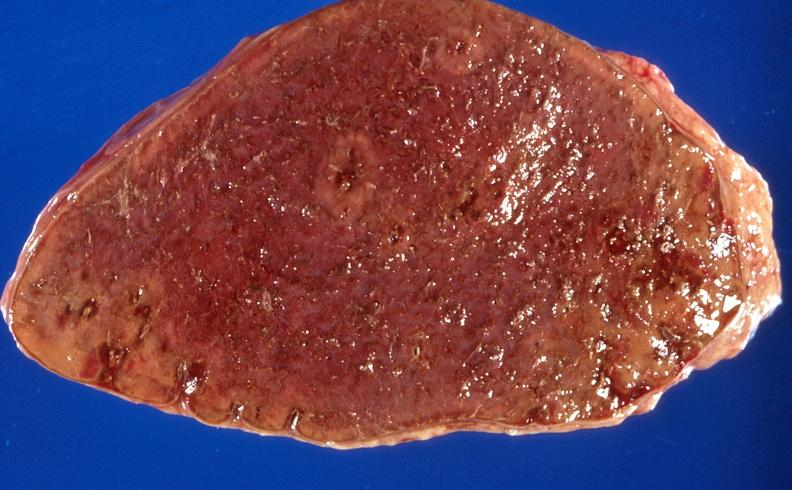s hematologic present?
Answer the question using a single word or phrase. Yes 